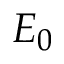<formula> <loc_0><loc_0><loc_500><loc_500>E _ { 0 }</formula> 